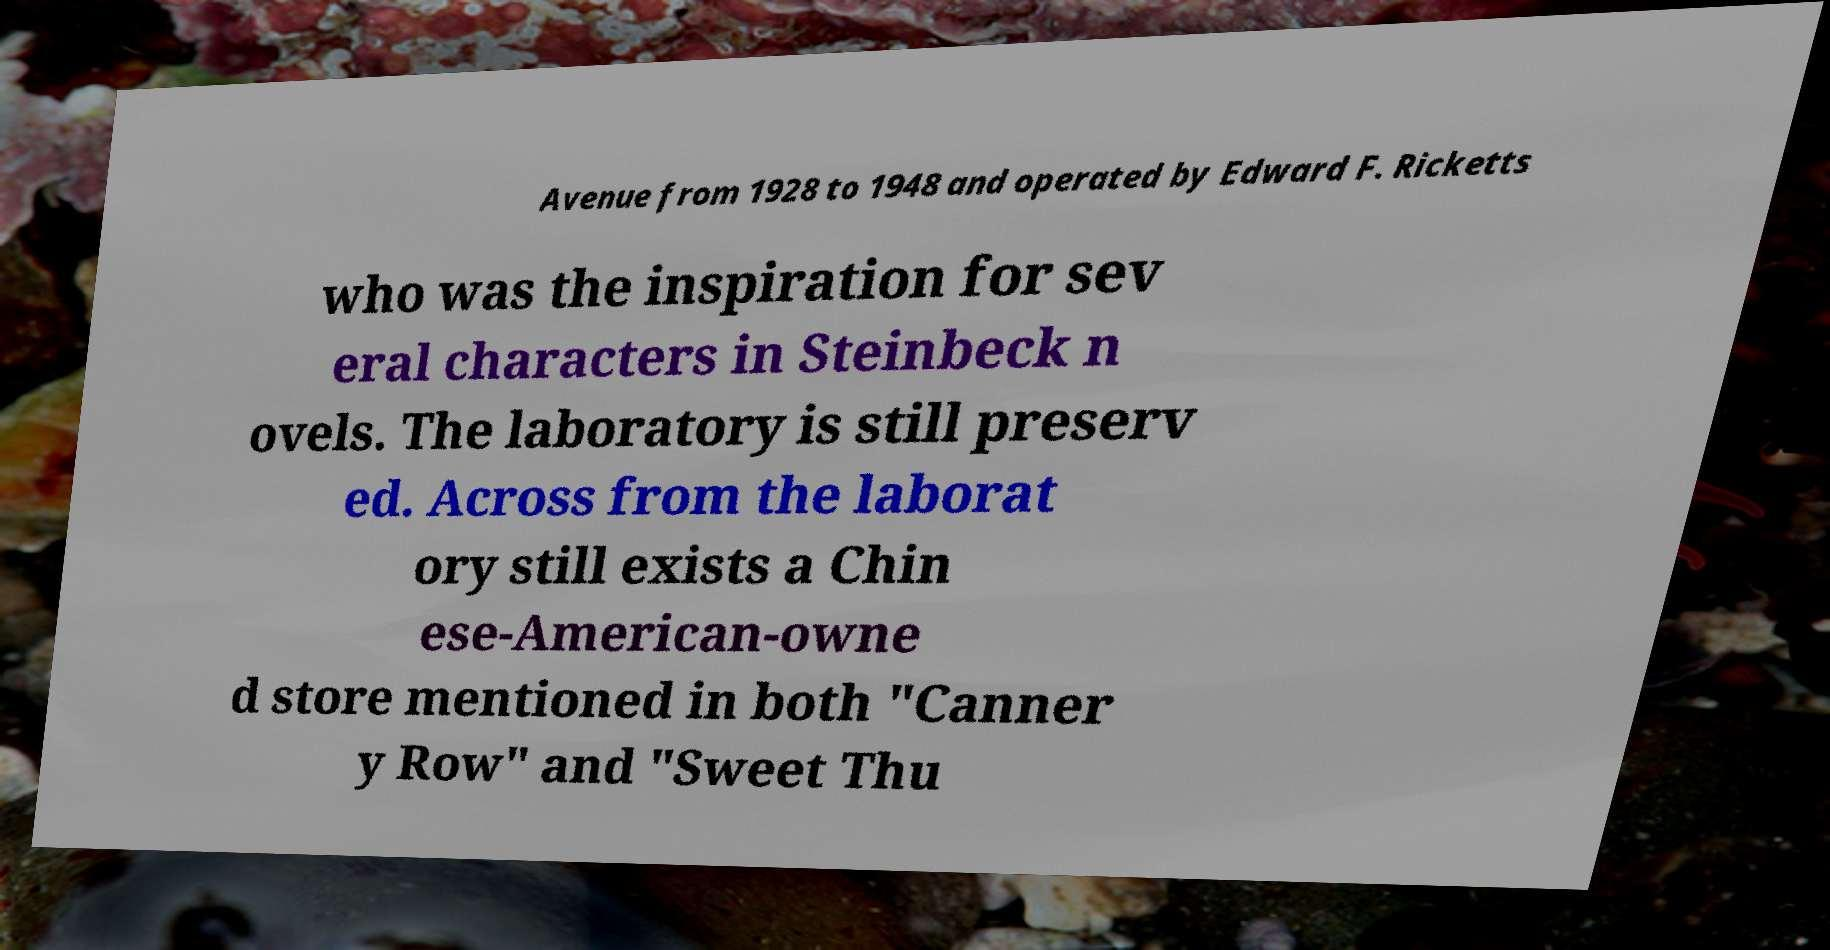I need the written content from this picture converted into text. Can you do that? Avenue from 1928 to 1948 and operated by Edward F. Ricketts who was the inspiration for sev eral characters in Steinbeck n ovels. The laboratory is still preserv ed. Across from the laborat ory still exists a Chin ese-American-owne d store mentioned in both "Canner y Row" and "Sweet Thu 